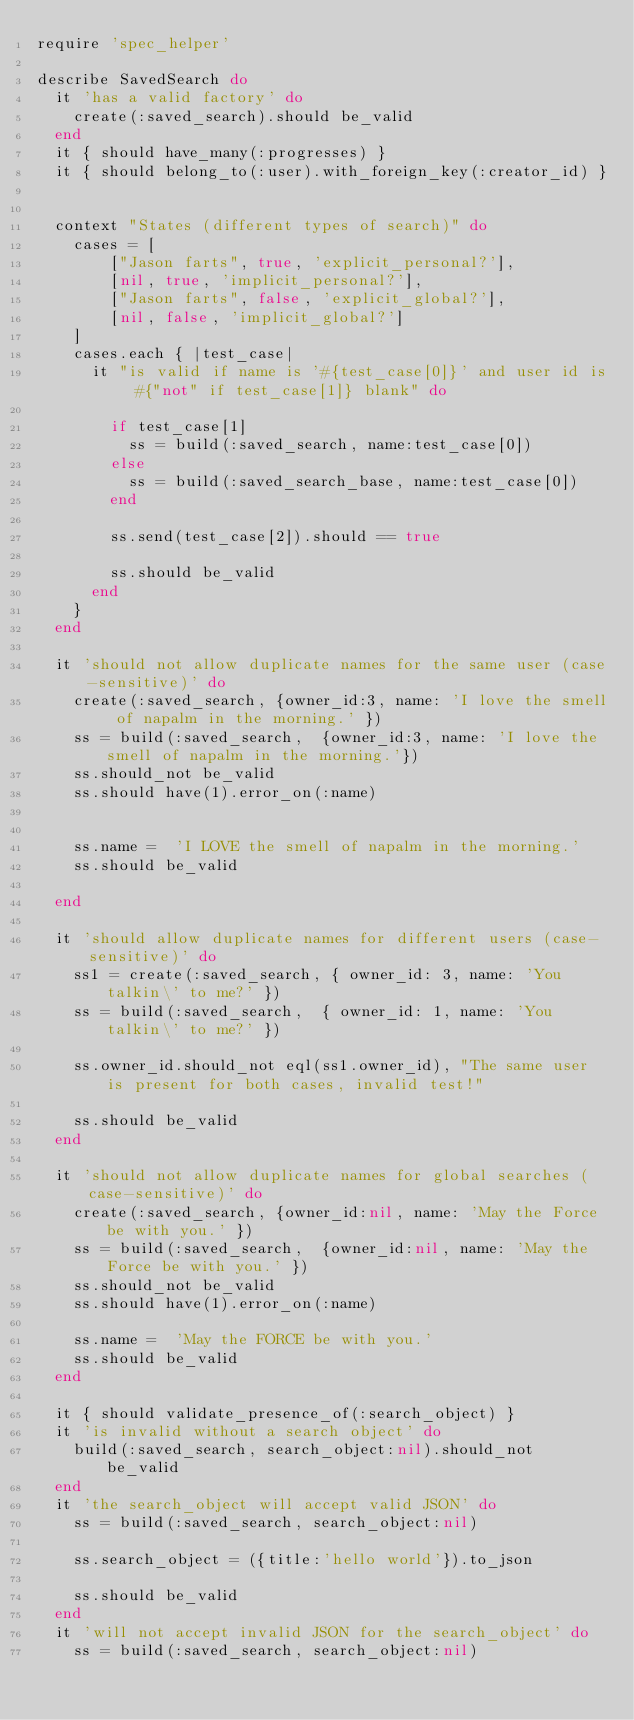<code> <loc_0><loc_0><loc_500><loc_500><_Ruby_>require 'spec_helper'

describe SavedSearch do
  it 'has a valid factory' do
    create(:saved_search).should be_valid
  end
  it { should have_many(:progresses) }
  it { should belong_to(:user).with_foreign_key(:creator_id) }


  context "States (different types of search)" do
    cases = [
        ["Jason farts", true, 'explicit_personal?'],
        [nil, true, 'implicit_personal?'],
        ["Jason farts", false, 'explicit_global?'],
        [nil, false, 'implicit_global?']
    ]
    cases.each { |test_case|
      it "is valid if name is '#{test_case[0]}' and user id is #{"not" if test_case[1]} blank" do

        if test_case[1]
          ss = build(:saved_search, name:test_case[0])
        else
          ss = build(:saved_search_base, name:test_case[0])
        end

        ss.send(test_case[2]).should == true

        ss.should be_valid
      end
    }
  end

  it 'should not allow duplicate names for the same user (case-sensitive)' do
    create(:saved_search, {owner_id:3, name: 'I love the smell of napalm in the morning.' })
    ss = build(:saved_search,  {owner_id:3, name: 'I love the smell of napalm in the morning.'})
    ss.should_not be_valid
    ss.should have(1).error_on(:name)


    ss.name =  'I LOVE the smell of napalm in the morning.'
    ss.should be_valid

  end

  it 'should allow duplicate names for different users (case-sensitive)' do
    ss1 = create(:saved_search, { owner_id: 3, name: 'You talkin\' to me?' })
    ss = build(:saved_search,  { owner_id: 1, name: 'You talkin\' to me?' })

    ss.owner_id.should_not eql(ss1.owner_id), "The same user is present for both cases, invalid test!"

    ss.should be_valid
  end

  it 'should not allow duplicate names for global searches (case-sensitive)' do
    create(:saved_search, {owner_id:nil, name: 'May the Force be with you.' })
    ss = build(:saved_search,  {owner_id:nil, name: 'May the Force be with you.' })
    ss.should_not be_valid
    ss.should have(1).error_on(:name)

    ss.name =  'May the FORCE be with you.'
    ss.should be_valid
  end

  it { should validate_presence_of(:search_object) }
  it 'is invalid without a search object' do
    build(:saved_search, search_object:nil).should_not be_valid
  end
  it 'the search_object will accept valid JSON' do
    ss = build(:saved_search, search_object:nil)

    ss.search_object = ({title:'hello world'}).to_json

    ss.should be_valid
  end
  it 'will not accept invalid JSON for the search_object' do
    ss = build(:saved_search, search_object:nil)
</code> 